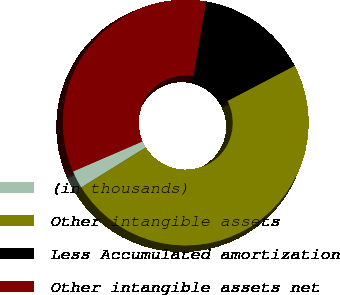Convert chart to OTSL. <chart><loc_0><loc_0><loc_500><loc_500><pie_chart><fcel>(in thousands)<fcel>Other intangible assets<fcel>Less Accumulated amortization<fcel>Other intangible assets net<nl><fcel>2.35%<fcel>48.82%<fcel>14.66%<fcel>34.16%<nl></chart> 